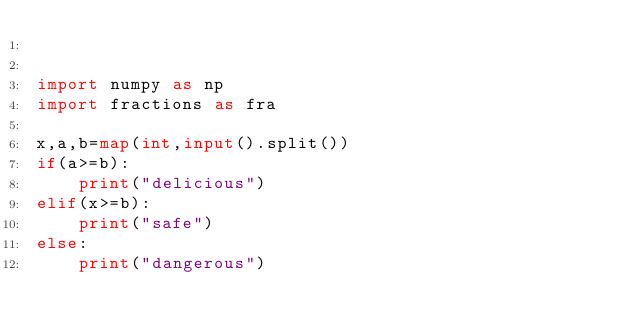<code> <loc_0><loc_0><loc_500><loc_500><_Python_>

import numpy as np
import fractions as fra

x,a,b=map(int,input().split())
if(a>=b):
    print("delicious")
elif(x>=b):
    print("safe")
else:
    print("dangerous")</code> 